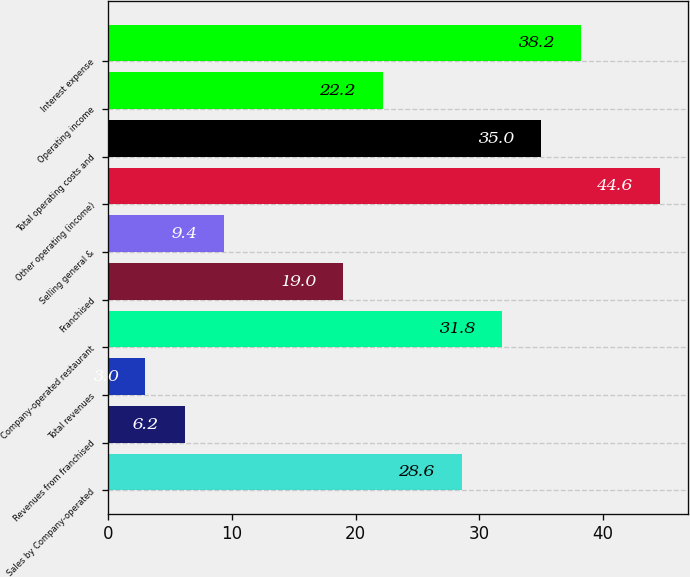Convert chart. <chart><loc_0><loc_0><loc_500><loc_500><bar_chart><fcel>Sales by Company-operated<fcel>Revenues from franchised<fcel>Total revenues<fcel>Company-operated restaurant<fcel>Franchised<fcel>Selling general &<fcel>Other operating (income)<fcel>Total operating costs and<fcel>Operating income<fcel>Interest expense<nl><fcel>28.6<fcel>6.2<fcel>3<fcel>31.8<fcel>19<fcel>9.4<fcel>44.6<fcel>35<fcel>22.2<fcel>38.2<nl></chart> 